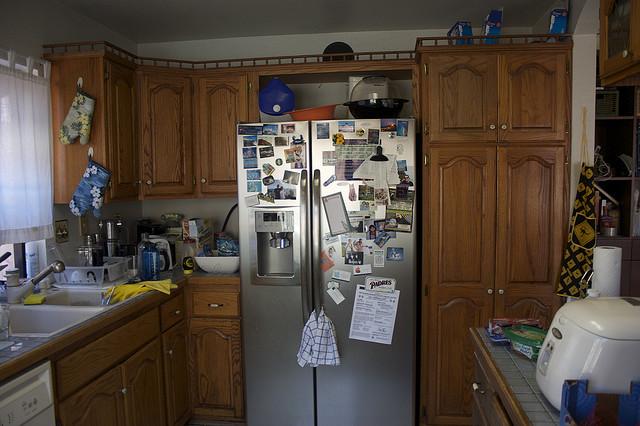Which side has the refrigerator handle?
Give a very brief answer. Both. What is hanging from the door handle?
Write a very short answer. Towel. Where is the bread machine?
Answer briefly. On counter. Do they have children?
Concise answer only. Yes. 